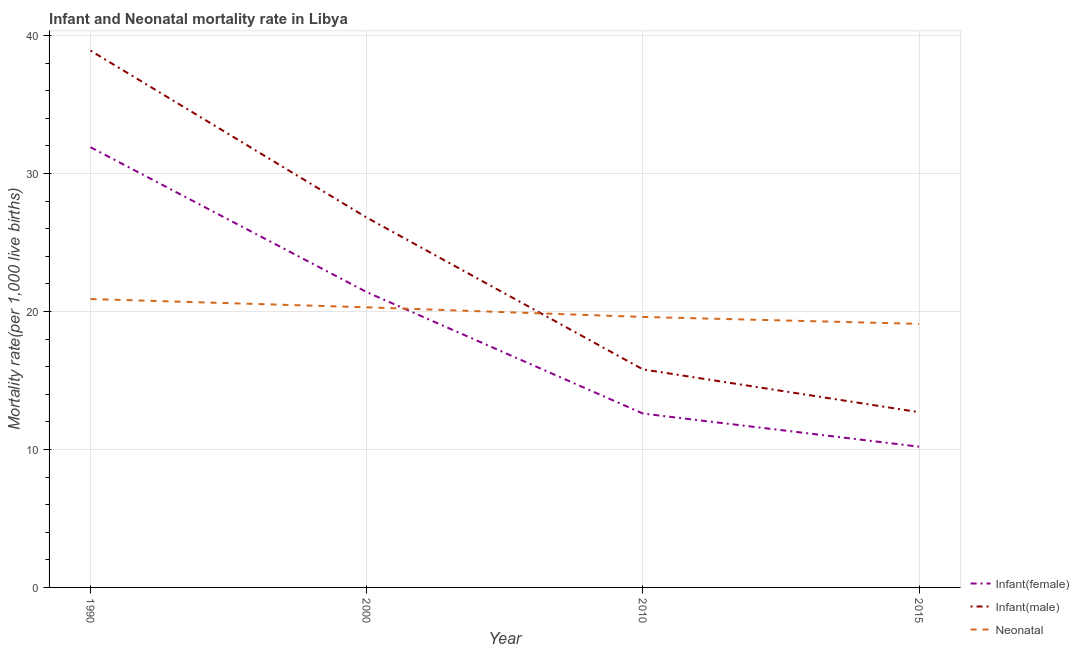How many different coloured lines are there?
Keep it short and to the point. 3. What is the infant mortality rate(female) in 1990?
Your answer should be very brief. 31.9. Across all years, what is the maximum infant mortality rate(male)?
Your answer should be compact. 38.9. In which year was the neonatal mortality rate minimum?
Offer a very short reply. 2015. What is the total infant mortality rate(male) in the graph?
Offer a very short reply. 94.2. What is the difference between the neonatal mortality rate in 2000 and that in 2015?
Make the answer very short. 1.2. What is the difference between the neonatal mortality rate in 2015 and the infant mortality rate(male) in 2000?
Offer a very short reply. -7.7. What is the average infant mortality rate(female) per year?
Ensure brevity in your answer.  19.02. In the year 2000, what is the difference between the infant mortality rate(male) and neonatal mortality rate?
Give a very brief answer. 6.5. What is the ratio of the neonatal mortality rate in 1990 to that in 2010?
Make the answer very short. 1.07. Is the infant mortality rate(female) in 2000 less than that in 2010?
Keep it short and to the point. No. Is the difference between the infant mortality rate(female) in 1990 and 2010 greater than the difference between the neonatal mortality rate in 1990 and 2010?
Offer a terse response. Yes. What is the difference between the highest and the second highest infant mortality rate(female)?
Offer a very short reply. 10.5. What is the difference between the highest and the lowest infant mortality rate(male)?
Give a very brief answer. 26.2. In how many years, is the infant mortality rate(male) greater than the average infant mortality rate(male) taken over all years?
Offer a terse response. 2. Is the sum of the neonatal mortality rate in 1990 and 2015 greater than the maximum infant mortality rate(male) across all years?
Provide a short and direct response. Yes. Is the neonatal mortality rate strictly greater than the infant mortality rate(female) over the years?
Your answer should be very brief. No. How many lines are there?
Your answer should be very brief. 3. Are the values on the major ticks of Y-axis written in scientific E-notation?
Provide a short and direct response. No. Does the graph contain any zero values?
Make the answer very short. No. Where does the legend appear in the graph?
Make the answer very short. Bottom right. How are the legend labels stacked?
Your answer should be compact. Vertical. What is the title of the graph?
Provide a succinct answer. Infant and Neonatal mortality rate in Libya. Does "Slovak Republic" appear as one of the legend labels in the graph?
Offer a very short reply. No. What is the label or title of the X-axis?
Offer a very short reply. Year. What is the label or title of the Y-axis?
Offer a terse response. Mortality rate(per 1,0 live births). What is the Mortality rate(per 1,000 live births) in Infant(female) in 1990?
Your answer should be very brief. 31.9. What is the Mortality rate(per 1,000 live births) in Infant(male) in 1990?
Provide a short and direct response. 38.9. What is the Mortality rate(per 1,000 live births) of Neonatal  in 1990?
Offer a terse response. 20.9. What is the Mortality rate(per 1,000 live births) in Infant(female) in 2000?
Offer a terse response. 21.4. What is the Mortality rate(per 1,000 live births) in Infant(male) in 2000?
Give a very brief answer. 26.8. What is the Mortality rate(per 1,000 live births) in Neonatal  in 2000?
Ensure brevity in your answer.  20.3. What is the Mortality rate(per 1,000 live births) of Infant(female) in 2010?
Provide a succinct answer. 12.6. What is the Mortality rate(per 1,000 live births) in Infant(male) in 2010?
Keep it short and to the point. 15.8. What is the Mortality rate(per 1,000 live births) of Neonatal  in 2010?
Give a very brief answer. 19.6. What is the Mortality rate(per 1,000 live births) of Infant(female) in 2015?
Your answer should be compact. 10.2. What is the Mortality rate(per 1,000 live births) of Infant(male) in 2015?
Your answer should be compact. 12.7. Across all years, what is the maximum Mortality rate(per 1,000 live births) in Infant(female)?
Offer a terse response. 31.9. Across all years, what is the maximum Mortality rate(per 1,000 live births) in Infant(male)?
Offer a terse response. 38.9. Across all years, what is the maximum Mortality rate(per 1,000 live births) in Neonatal ?
Your response must be concise. 20.9. Across all years, what is the minimum Mortality rate(per 1,000 live births) in Infant(female)?
Your answer should be very brief. 10.2. Across all years, what is the minimum Mortality rate(per 1,000 live births) of Infant(male)?
Your response must be concise. 12.7. Across all years, what is the minimum Mortality rate(per 1,000 live births) in Neonatal ?
Provide a short and direct response. 19.1. What is the total Mortality rate(per 1,000 live births) of Infant(female) in the graph?
Your response must be concise. 76.1. What is the total Mortality rate(per 1,000 live births) in Infant(male) in the graph?
Your response must be concise. 94.2. What is the total Mortality rate(per 1,000 live births) of Neonatal  in the graph?
Make the answer very short. 79.9. What is the difference between the Mortality rate(per 1,000 live births) of Infant(male) in 1990 and that in 2000?
Ensure brevity in your answer.  12.1. What is the difference between the Mortality rate(per 1,000 live births) in Neonatal  in 1990 and that in 2000?
Keep it short and to the point. 0.6. What is the difference between the Mortality rate(per 1,000 live births) of Infant(female) in 1990 and that in 2010?
Ensure brevity in your answer.  19.3. What is the difference between the Mortality rate(per 1,000 live births) of Infant(male) in 1990 and that in 2010?
Ensure brevity in your answer.  23.1. What is the difference between the Mortality rate(per 1,000 live births) in Infant(female) in 1990 and that in 2015?
Your answer should be compact. 21.7. What is the difference between the Mortality rate(per 1,000 live births) in Infant(male) in 1990 and that in 2015?
Your answer should be compact. 26.2. What is the difference between the Mortality rate(per 1,000 live births) of Neonatal  in 1990 and that in 2015?
Make the answer very short. 1.8. What is the difference between the Mortality rate(per 1,000 live births) in Infant(female) in 2000 and that in 2010?
Offer a very short reply. 8.8. What is the difference between the Mortality rate(per 1,000 live births) in Infant(male) in 2000 and that in 2010?
Keep it short and to the point. 11. What is the difference between the Mortality rate(per 1,000 live births) in Neonatal  in 2000 and that in 2010?
Provide a short and direct response. 0.7. What is the difference between the Mortality rate(per 1,000 live births) in Infant(female) in 2000 and that in 2015?
Offer a very short reply. 11.2. What is the difference between the Mortality rate(per 1,000 live births) of Infant(male) in 2000 and that in 2015?
Give a very brief answer. 14.1. What is the difference between the Mortality rate(per 1,000 live births) in Neonatal  in 2000 and that in 2015?
Your answer should be very brief. 1.2. What is the difference between the Mortality rate(per 1,000 live births) in Neonatal  in 2010 and that in 2015?
Give a very brief answer. 0.5. What is the difference between the Mortality rate(per 1,000 live births) of Infant(female) in 1990 and the Mortality rate(per 1,000 live births) of Infant(male) in 2000?
Provide a short and direct response. 5.1. What is the difference between the Mortality rate(per 1,000 live births) of Infant(female) in 1990 and the Mortality rate(per 1,000 live births) of Infant(male) in 2010?
Ensure brevity in your answer.  16.1. What is the difference between the Mortality rate(per 1,000 live births) in Infant(female) in 1990 and the Mortality rate(per 1,000 live births) in Neonatal  in 2010?
Offer a terse response. 12.3. What is the difference between the Mortality rate(per 1,000 live births) of Infant(male) in 1990 and the Mortality rate(per 1,000 live births) of Neonatal  in 2010?
Provide a succinct answer. 19.3. What is the difference between the Mortality rate(per 1,000 live births) of Infant(female) in 1990 and the Mortality rate(per 1,000 live births) of Infant(male) in 2015?
Your answer should be compact. 19.2. What is the difference between the Mortality rate(per 1,000 live births) in Infant(female) in 1990 and the Mortality rate(per 1,000 live births) in Neonatal  in 2015?
Your answer should be very brief. 12.8. What is the difference between the Mortality rate(per 1,000 live births) in Infant(male) in 1990 and the Mortality rate(per 1,000 live births) in Neonatal  in 2015?
Give a very brief answer. 19.8. What is the difference between the Mortality rate(per 1,000 live births) of Infant(female) in 2000 and the Mortality rate(per 1,000 live births) of Infant(male) in 2015?
Make the answer very short. 8.7. What is the difference between the Mortality rate(per 1,000 live births) in Infant(female) in 2000 and the Mortality rate(per 1,000 live births) in Neonatal  in 2015?
Provide a short and direct response. 2.3. What is the difference between the Mortality rate(per 1,000 live births) of Infant(male) in 2000 and the Mortality rate(per 1,000 live births) of Neonatal  in 2015?
Provide a short and direct response. 7.7. What is the difference between the Mortality rate(per 1,000 live births) in Infant(male) in 2010 and the Mortality rate(per 1,000 live births) in Neonatal  in 2015?
Keep it short and to the point. -3.3. What is the average Mortality rate(per 1,000 live births) in Infant(female) per year?
Ensure brevity in your answer.  19.02. What is the average Mortality rate(per 1,000 live births) of Infant(male) per year?
Provide a succinct answer. 23.55. What is the average Mortality rate(per 1,000 live births) in Neonatal  per year?
Your response must be concise. 19.98. In the year 1990, what is the difference between the Mortality rate(per 1,000 live births) in Infant(female) and Mortality rate(per 1,000 live births) in Infant(male)?
Offer a very short reply. -7. In the year 1990, what is the difference between the Mortality rate(per 1,000 live births) of Infant(female) and Mortality rate(per 1,000 live births) of Neonatal ?
Your response must be concise. 11. In the year 2000, what is the difference between the Mortality rate(per 1,000 live births) in Infant(female) and Mortality rate(per 1,000 live births) in Infant(male)?
Provide a succinct answer. -5.4. In the year 2000, what is the difference between the Mortality rate(per 1,000 live births) in Infant(female) and Mortality rate(per 1,000 live births) in Neonatal ?
Your answer should be compact. 1.1. In the year 2000, what is the difference between the Mortality rate(per 1,000 live births) of Infant(male) and Mortality rate(per 1,000 live births) of Neonatal ?
Your answer should be very brief. 6.5. In the year 2010, what is the difference between the Mortality rate(per 1,000 live births) of Infant(female) and Mortality rate(per 1,000 live births) of Neonatal ?
Ensure brevity in your answer.  -7. What is the ratio of the Mortality rate(per 1,000 live births) of Infant(female) in 1990 to that in 2000?
Ensure brevity in your answer.  1.49. What is the ratio of the Mortality rate(per 1,000 live births) in Infant(male) in 1990 to that in 2000?
Ensure brevity in your answer.  1.45. What is the ratio of the Mortality rate(per 1,000 live births) in Neonatal  in 1990 to that in 2000?
Provide a succinct answer. 1.03. What is the ratio of the Mortality rate(per 1,000 live births) in Infant(female) in 1990 to that in 2010?
Provide a succinct answer. 2.53. What is the ratio of the Mortality rate(per 1,000 live births) in Infant(male) in 1990 to that in 2010?
Keep it short and to the point. 2.46. What is the ratio of the Mortality rate(per 1,000 live births) in Neonatal  in 1990 to that in 2010?
Give a very brief answer. 1.07. What is the ratio of the Mortality rate(per 1,000 live births) of Infant(female) in 1990 to that in 2015?
Offer a very short reply. 3.13. What is the ratio of the Mortality rate(per 1,000 live births) in Infant(male) in 1990 to that in 2015?
Give a very brief answer. 3.06. What is the ratio of the Mortality rate(per 1,000 live births) in Neonatal  in 1990 to that in 2015?
Offer a terse response. 1.09. What is the ratio of the Mortality rate(per 1,000 live births) of Infant(female) in 2000 to that in 2010?
Provide a succinct answer. 1.7. What is the ratio of the Mortality rate(per 1,000 live births) of Infant(male) in 2000 to that in 2010?
Ensure brevity in your answer.  1.7. What is the ratio of the Mortality rate(per 1,000 live births) of Neonatal  in 2000 to that in 2010?
Offer a very short reply. 1.04. What is the ratio of the Mortality rate(per 1,000 live births) of Infant(female) in 2000 to that in 2015?
Provide a succinct answer. 2.1. What is the ratio of the Mortality rate(per 1,000 live births) of Infant(male) in 2000 to that in 2015?
Give a very brief answer. 2.11. What is the ratio of the Mortality rate(per 1,000 live births) in Neonatal  in 2000 to that in 2015?
Give a very brief answer. 1.06. What is the ratio of the Mortality rate(per 1,000 live births) of Infant(female) in 2010 to that in 2015?
Offer a very short reply. 1.24. What is the ratio of the Mortality rate(per 1,000 live births) in Infant(male) in 2010 to that in 2015?
Provide a succinct answer. 1.24. What is the ratio of the Mortality rate(per 1,000 live births) in Neonatal  in 2010 to that in 2015?
Provide a short and direct response. 1.03. What is the difference between the highest and the second highest Mortality rate(per 1,000 live births) in Infant(female)?
Your answer should be compact. 10.5. What is the difference between the highest and the second highest Mortality rate(per 1,000 live births) of Infant(male)?
Make the answer very short. 12.1. What is the difference between the highest and the second highest Mortality rate(per 1,000 live births) in Neonatal ?
Provide a short and direct response. 0.6. What is the difference between the highest and the lowest Mortality rate(per 1,000 live births) of Infant(female)?
Your answer should be compact. 21.7. What is the difference between the highest and the lowest Mortality rate(per 1,000 live births) of Infant(male)?
Provide a short and direct response. 26.2. 